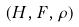Convert formula to latex. <formula><loc_0><loc_0><loc_500><loc_500>( H , F , \rho )</formula> 